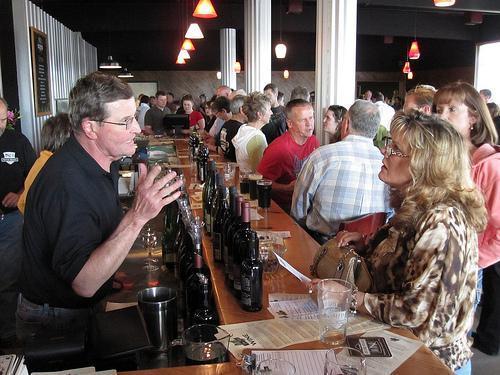How many people are wearing glasses?
Give a very brief answer. 2. 